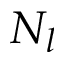Convert formula to latex. <formula><loc_0><loc_0><loc_500><loc_500>N _ { l }</formula> 